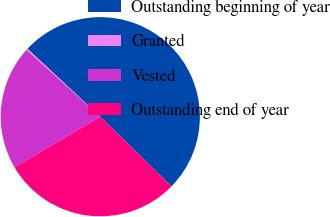<chart> <loc_0><loc_0><loc_500><loc_500><pie_chart><fcel>Outstanding beginning of year<fcel>Granted<fcel>Vested<fcel>Outstanding end of year<nl><fcel>50.36%<fcel>0.24%<fcel>20.19%<fcel>29.2%<nl></chart> 